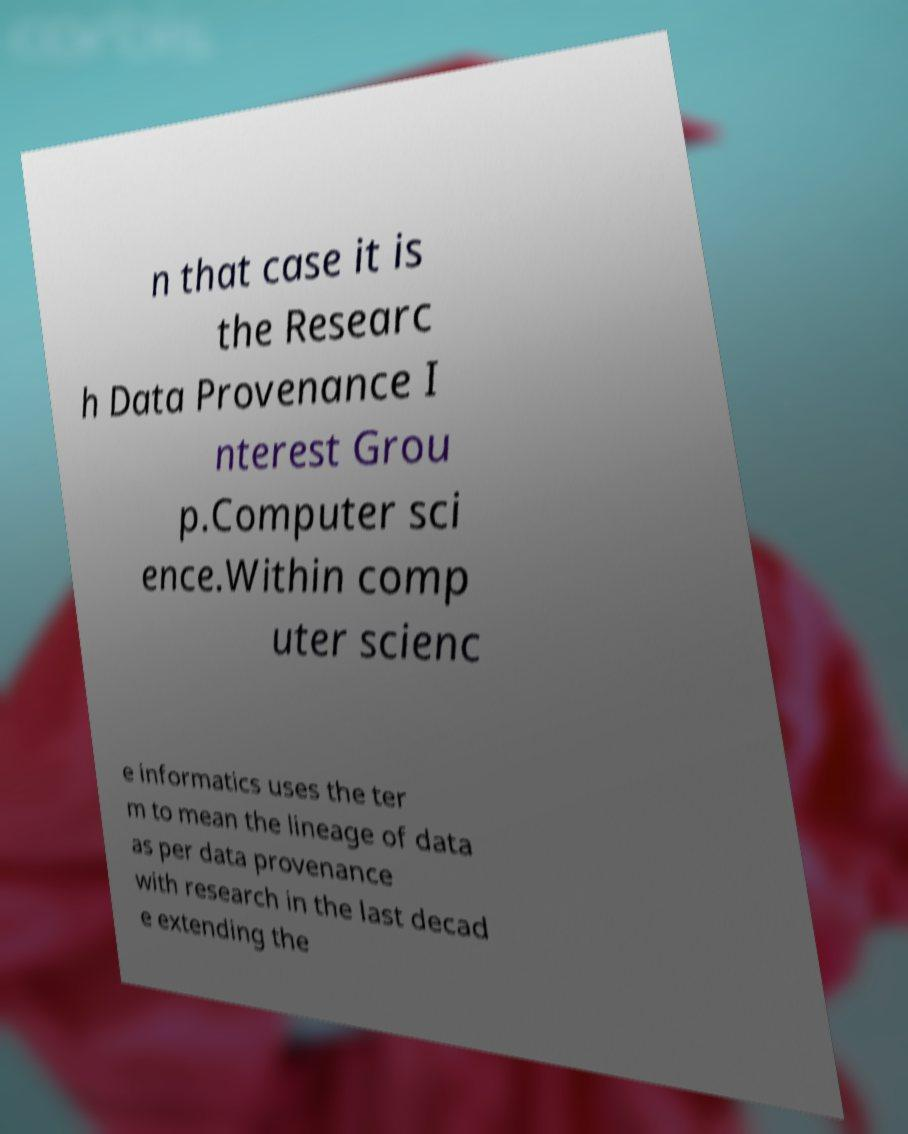I need the written content from this picture converted into text. Can you do that? n that case it is the Researc h Data Provenance I nterest Grou p.Computer sci ence.Within comp uter scienc e informatics uses the ter m to mean the lineage of data as per data provenance with research in the last decad e extending the 